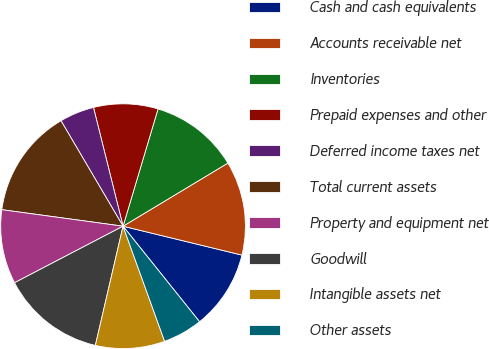Convert chart to OTSL. <chart><loc_0><loc_0><loc_500><loc_500><pie_chart><fcel>Cash and cash equivalents<fcel>Accounts receivable net<fcel>Inventories<fcel>Prepaid expenses and other<fcel>Deferred income taxes net<fcel>Total current assets<fcel>Property and equipment net<fcel>Goodwill<fcel>Intangible assets net<fcel>Other assets<nl><fcel>10.46%<fcel>12.42%<fcel>11.76%<fcel>8.5%<fcel>4.58%<fcel>14.38%<fcel>9.8%<fcel>13.72%<fcel>9.15%<fcel>5.23%<nl></chart> 